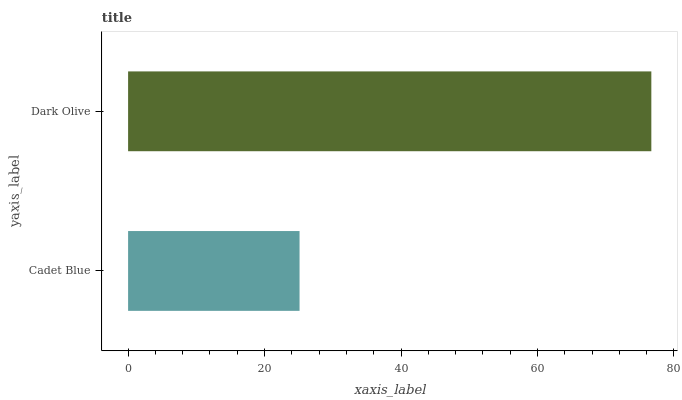Is Cadet Blue the minimum?
Answer yes or no. Yes. Is Dark Olive the maximum?
Answer yes or no. Yes. Is Dark Olive the minimum?
Answer yes or no. No. Is Dark Olive greater than Cadet Blue?
Answer yes or no. Yes. Is Cadet Blue less than Dark Olive?
Answer yes or no. Yes. Is Cadet Blue greater than Dark Olive?
Answer yes or no. No. Is Dark Olive less than Cadet Blue?
Answer yes or no. No. Is Dark Olive the high median?
Answer yes or no. Yes. Is Cadet Blue the low median?
Answer yes or no. Yes. Is Cadet Blue the high median?
Answer yes or no. No. Is Dark Olive the low median?
Answer yes or no. No. 